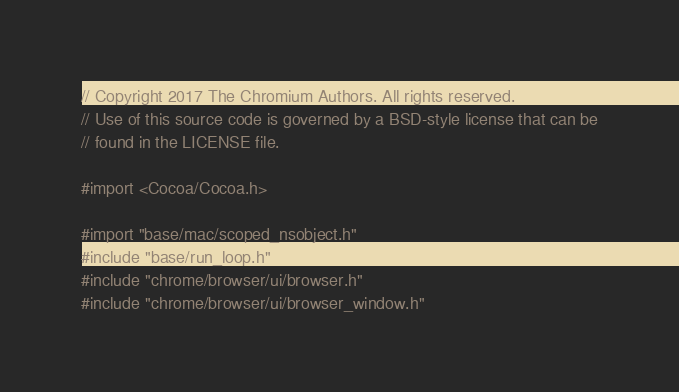Convert code to text. <code><loc_0><loc_0><loc_500><loc_500><_ObjectiveC_>// Copyright 2017 The Chromium Authors. All rights reserved.
// Use of this source code is governed by a BSD-style license that can be
// found in the LICENSE file.

#import <Cocoa/Cocoa.h>

#import "base/mac/scoped_nsobject.h"
#include "base/run_loop.h"
#include "chrome/browser/ui/browser.h"
#include "chrome/browser/ui/browser_window.h"</code> 